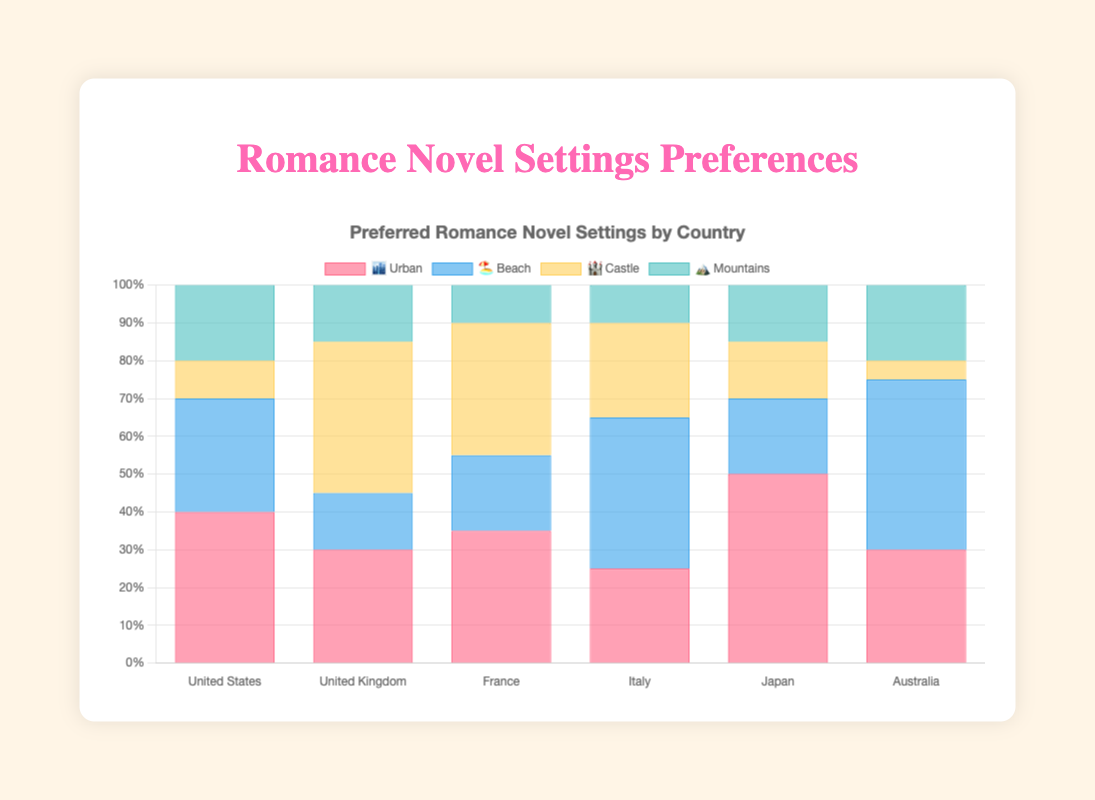What is the most preferred romance novel setting in Japan? The figure shows the preferences for different settings in Japan. The highest percentage bar for Japan is for "Urban" (🏙️) at 50%. So, the most preferred setting in Japan is "Urban" (🏙️).
Answer: Urban (🏙️) Which country has the highest preference for beach settings? To find the country with the highest preference for beach settings, look at the "Beach" (🏖️) series across all countries. Australia has the highest bar for this setting at 45%.
Answer: Australia Compare the preferences for castles in the United Kingdom and France. Which country prefers this setting more? Check the percentages for the "Castle" (🏰) setting in both the United Kingdom and France. The United Kingdom has a preference of 40%, while France has 35%. Thus, the United Kingdom prefers castle settings more.
Answer: United Kingdom What is the least preferred setting in the United States? Look at the United States bars for all settings and identify the smallest percentage. The smallest bar is for "Castle" (🏰) at 10%.
Answer: Castle (🏰) Calculate the total percentage of Urban and Beach settings in Italy. Add the percentages for Urban (25%) and Beach (40%) settings in Italy. 25% + 40% = 65%.
Answer: 65% What is the combined preference for Mountains and Castles in France? Add the percentages for Mountains (10%) and Castles (35%) in France. 10% + 35% = 45%.
Answer: 45% How does the preference for Urban settings in the United States compare to that in France? Compare the "Urban" (🏙️) percentages: the United States has 40%, and France has 35%. Thus, the United States has a higher preference for Urban settings.
Answer: The United States has a higher preference Which country exhibits a higher preference for Mountain settings: Japan or Australia? Look at the percentages for "Mountains" (🏔️) in Japan and Australia. Both countries have an equal preference of 20%.
Answer: Both are equal What is the average preference for Beach settings across all countries? To find the average, sum the percentages of Beach (🏖️) settings for all countries and divide by the number of countries. (30+15+20+40+20+45) = 170; 170 / 6 = 28.33%
Answer: 28.33% 